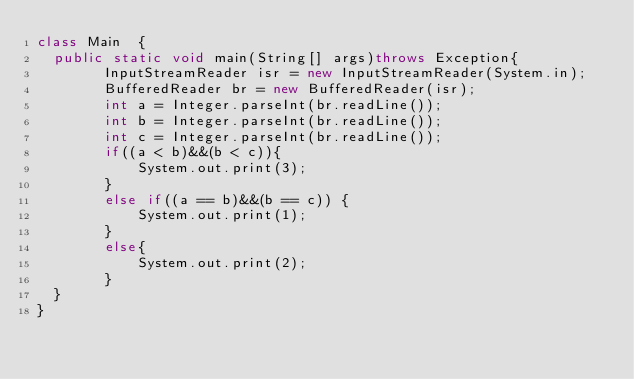<code> <loc_0><loc_0><loc_500><loc_500><_Java_>class Main  {
	public static void main(String[] args)throws Exception{
        InputStreamReader isr = new InputStreamReader(System.in);
        BufferedReader br = new BufferedReader(isr);
        int a = Integer.parseInt(br.readLine());
        int b = Integer.parseInt(br.readLine());
        int c = Integer.parseInt(br.readLine());
        if((a < b)&&(b < c)){
            System.out.print(3);
        }
        else if((a == b)&&(b == c)) {
            System.out.print(1);
        }
        else{
            System.out.print(2);
        }
	}
}
</code> 